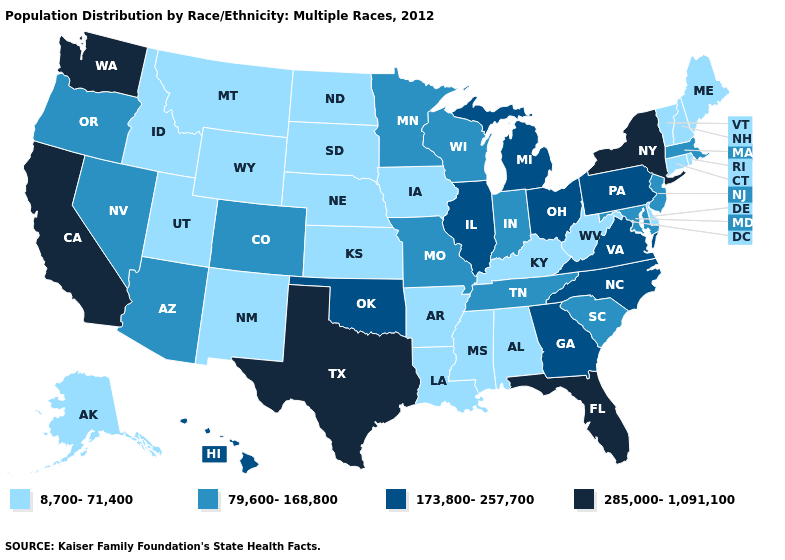Does the map have missing data?
Be succinct. No. Among the states that border Utah , does Arizona have the highest value?
Be succinct. Yes. Does Georgia have a lower value than California?
Keep it brief. Yes. Does California have a higher value than North Dakota?
Keep it brief. Yes. What is the lowest value in states that border Maine?
Give a very brief answer. 8,700-71,400. What is the value of Michigan?
Answer briefly. 173,800-257,700. Which states have the highest value in the USA?
Concise answer only. California, Florida, New York, Texas, Washington. Does Idaho have the highest value in the West?
Concise answer only. No. Is the legend a continuous bar?
Give a very brief answer. No. Does Texas have the highest value in the South?
Answer briefly. Yes. Name the states that have a value in the range 79,600-168,800?
Concise answer only. Arizona, Colorado, Indiana, Maryland, Massachusetts, Minnesota, Missouri, Nevada, New Jersey, Oregon, South Carolina, Tennessee, Wisconsin. Name the states that have a value in the range 8,700-71,400?
Concise answer only. Alabama, Alaska, Arkansas, Connecticut, Delaware, Idaho, Iowa, Kansas, Kentucky, Louisiana, Maine, Mississippi, Montana, Nebraska, New Hampshire, New Mexico, North Dakota, Rhode Island, South Dakota, Utah, Vermont, West Virginia, Wyoming. Name the states that have a value in the range 285,000-1,091,100?
Answer briefly. California, Florida, New York, Texas, Washington. Among the states that border Georgia , which have the highest value?
Short answer required. Florida. Name the states that have a value in the range 79,600-168,800?
Concise answer only. Arizona, Colorado, Indiana, Maryland, Massachusetts, Minnesota, Missouri, Nevada, New Jersey, Oregon, South Carolina, Tennessee, Wisconsin. 